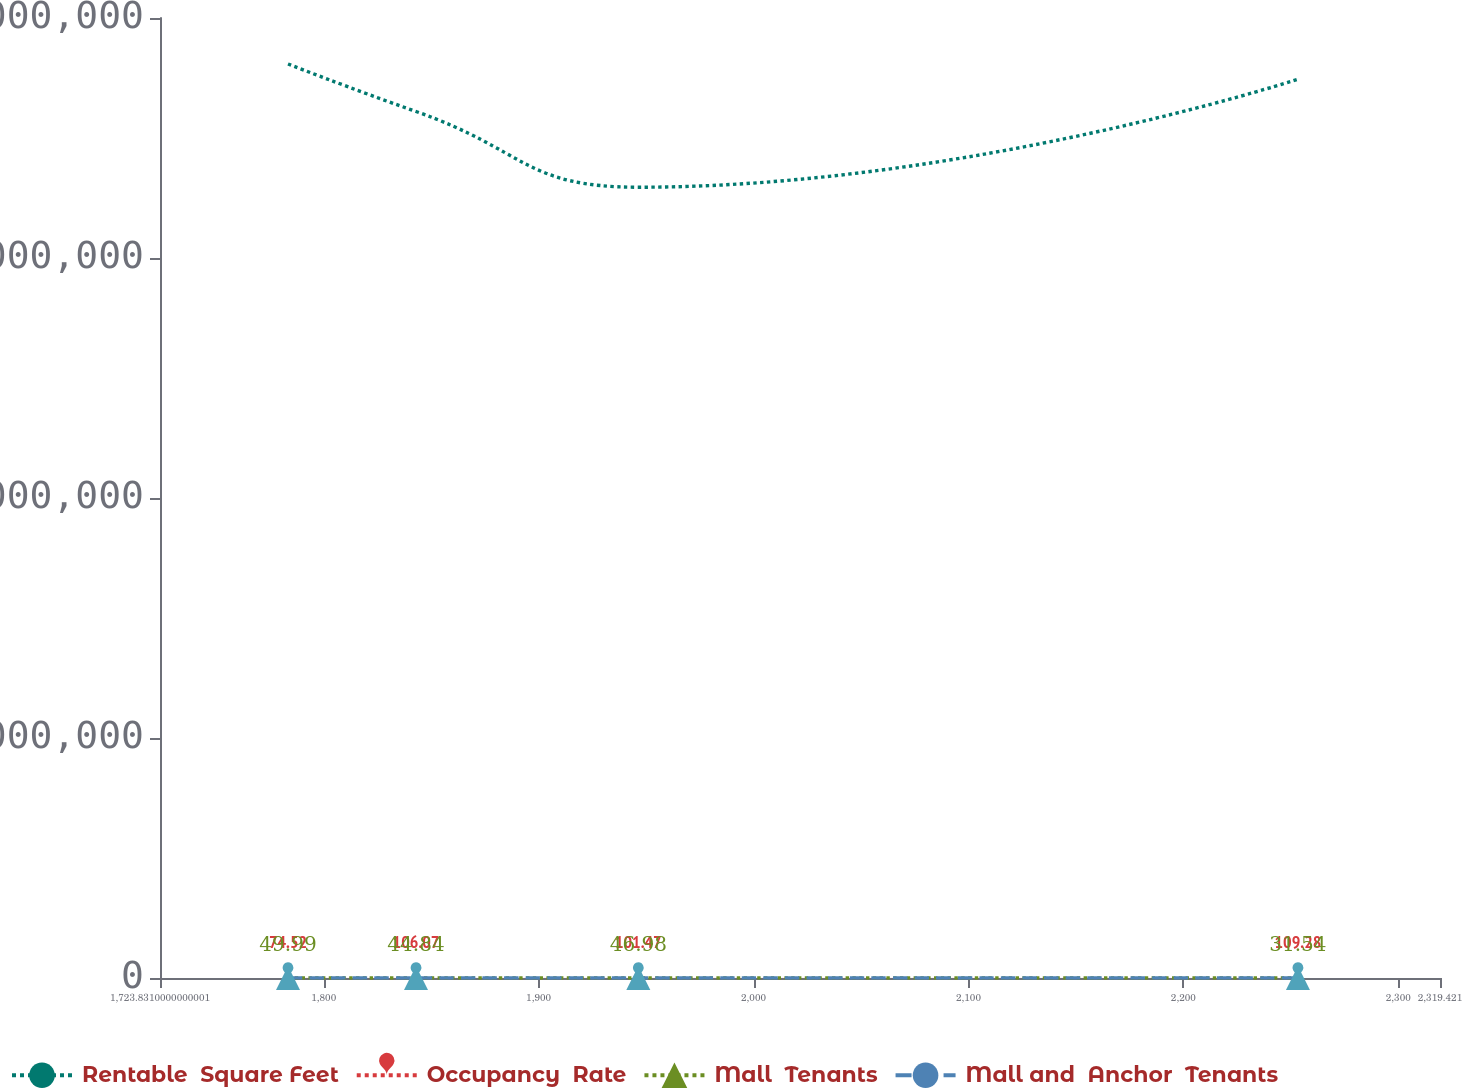<chart> <loc_0><loc_0><loc_500><loc_500><line_chart><ecel><fcel>Rentable  Square Feet<fcel>Occupancy  Rate<fcel>Mall  Tenants<fcel>Mall and  Anchor  Tenants<nl><fcel>1783.39<fcel>3.8084e+06<fcel>74.52<fcel>49.99<fcel>22.45<nl><fcel>1842.95<fcel>3.61051e+06<fcel>106.07<fcel>44.84<fcel>25.82<nl><fcel>1946.39<fcel>3.29494e+06<fcel>101.47<fcel>46.98<fcel>27.3<nl><fcel>2253.31<fcel>3.74475e+06<fcel>109.28<fcel>31.54<fcel>18.43<nl><fcel>2378.98<fcel>3.93146e+06<fcel>85<fcel>28.62<fcel>19.78<nl></chart> 